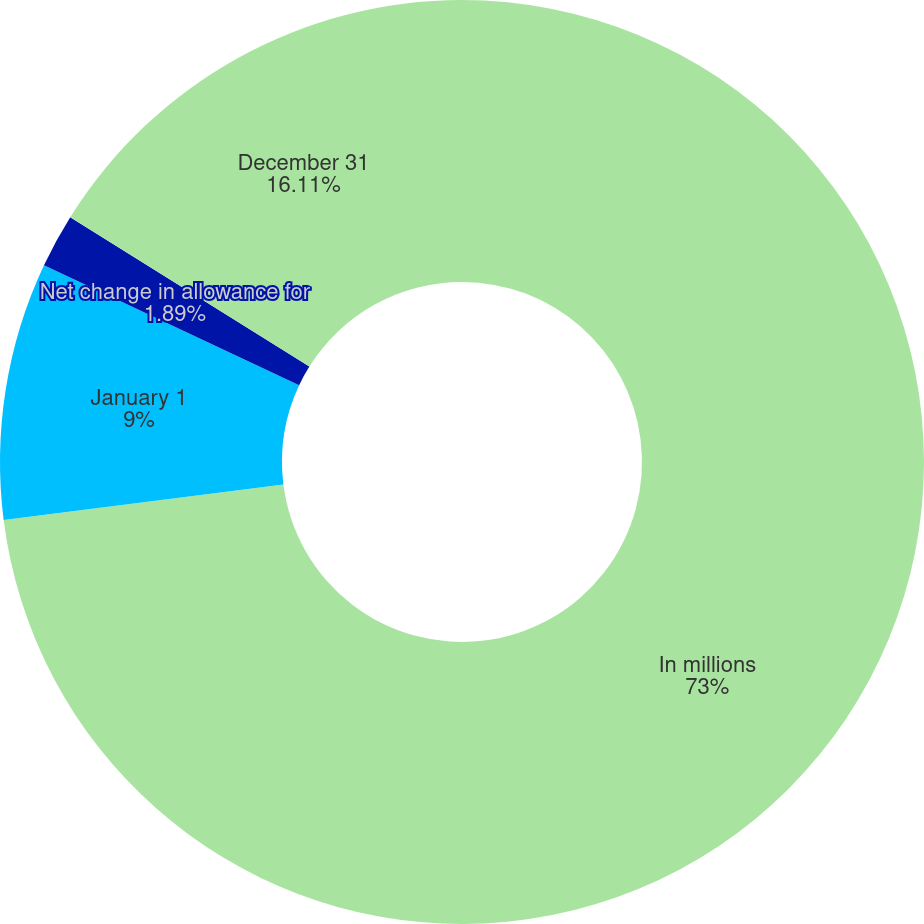<chart> <loc_0><loc_0><loc_500><loc_500><pie_chart><fcel>In millions<fcel>January 1<fcel>Net change in allowance for<fcel>December 31<nl><fcel>73.0%<fcel>9.0%<fcel>1.89%<fcel>16.11%<nl></chart> 